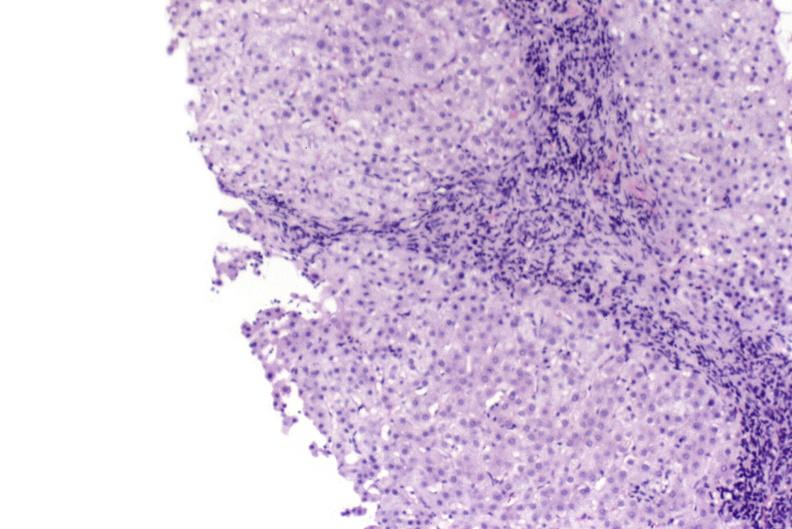s the superior vena cava present?
Answer the question using a single word or phrase. No 